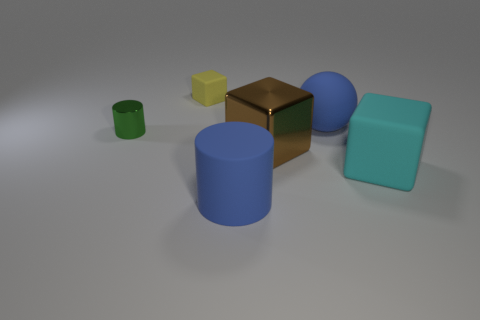How many matte things are either big blue objects or blue spheres?
Keep it short and to the point. 2. Are there any matte objects that are behind the small thing in front of the yellow rubber object?
Offer a terse response. Yes. Does the cylinder that is behind the brown object have the same material as the brown block?
Offer a terse response. Yes. What number of other objects are there of the same color as the big cylinder?
Ensure brevity in your answer.  1. Do the big ball and the large cylinder have the same color?
Ensure brevity in your answer.  Yes. How big is the metal thing that is to the left of the brown cube in front of the green object?
Make the answer very short. Small. Is the cube that is in front of the large brown object made of the same material as the brown block in front of the green object?
Offer a terse response. No. Is the color of the object in front of the large cyan matte cube the same as the matte ball?
Give a very brief answer. Yes. What number of rubber blocks are left of the large blue cylinder?
Provide a succinct answer. 1. Does the large brown cube have the same material as the cylinder that is behind the large matte cylinder?
Ensure brevity in your answer.  Yes. 